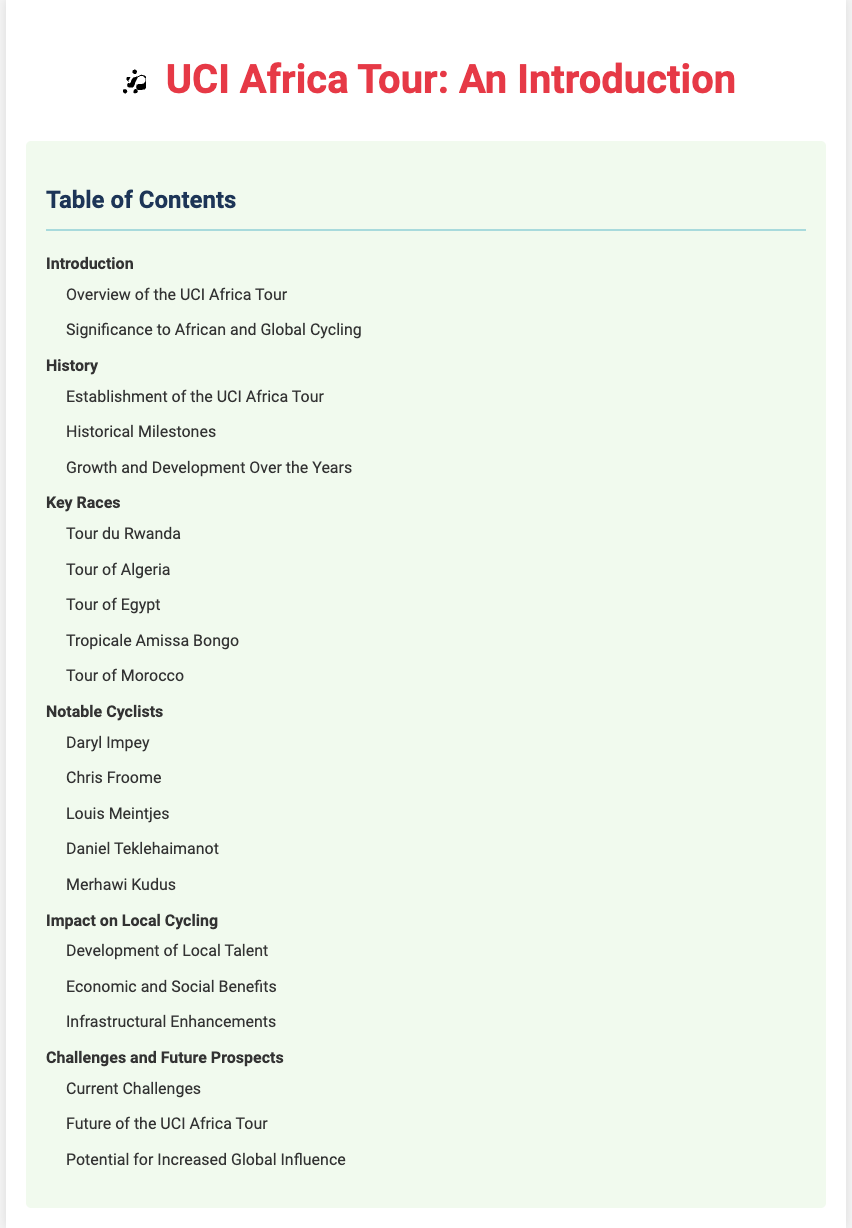what is the title of the document? The title is presented prominently at the top of the document, indicating the main subject of the content.
Answer: UCI Africa Tour: An Introduction how many main sections are in the table of contents? The table of contents lists the main sections that organize the content of the document, which can be counted.
Answer: 6 what is the first subtopic under "History"? The subtopics under "History" describe different historical aspects. The first one can be directly taken from the structure presented.
Answer: Establishment of the UCI Africa Tour who is listed as a notable cyclist? The document contains specific names of notable cyclists, and one can be selected from the provided list.
Answer: Daryl Impey what is the last key race mentioned? The last key race in the "Key Races" section is the final entry in that list.
Answer: Tour of Morocco what does the impact section focus on? The impact section outlines specific areas where the UCI Africa Tour has made contributions.
Answer: Development of Local Talent what is the focus of the "Challenges and Future Prospects" section? This section is highlighted by specific challenges and future considerations that relate to the UCI Africa Tour.
Answer: Current Challenges how does the document structure the content? The document organizes its content into sections and subsections, indicating a hierarchical structure for clarity.
Answer: Hierarchical Sections 